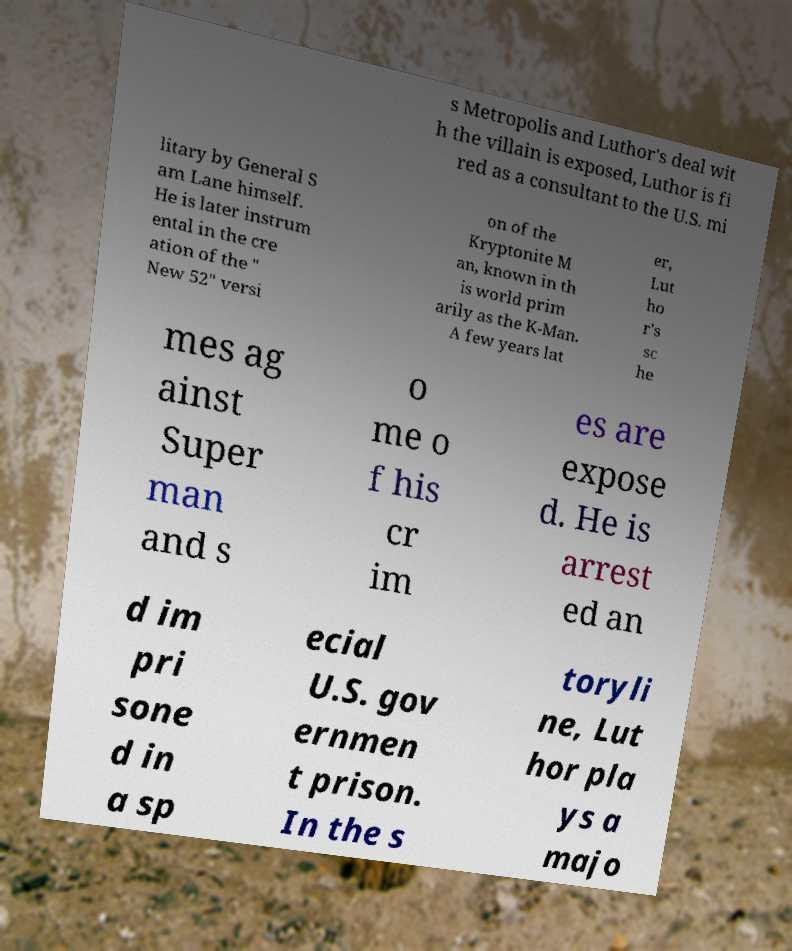Can you accurately transcribe the text from the provided image for me? s Metropolis and Luthor's deal wit h the villain is exposed, Luthor is fi red as a consultant to the U.S. mi litary by General S am Lane himself. He is later instrum ental in the cre ation of the " New 52" versi on of the Kryptonite M an, known in th is world prim arily as the K-Man. A few years lat er, Lut ho r's sc he mes ag ainst Super man and s o me o f his cr im es are expose d. He is arrest ed an d im pri sone d in a sp ecial U.S. gov ernmen t prison. In the s toryli ne, Lut hor pla ys a majo 